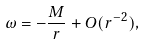Convert formula to latex. <formula><loc_0><loc_0><loc_500><loc_500>\omega = - \frac { M } { r } + O ( r ^ { - 2 } ) ,</formula> 